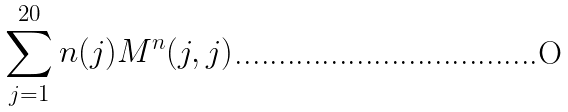Convert formula to latex. <formula><loc_0><loc_0><loc_500><loc_500>\sum _ { j = 1 } ^ { 2 0 } n ( j ) M ^ { n } ( j , j )</formula> 